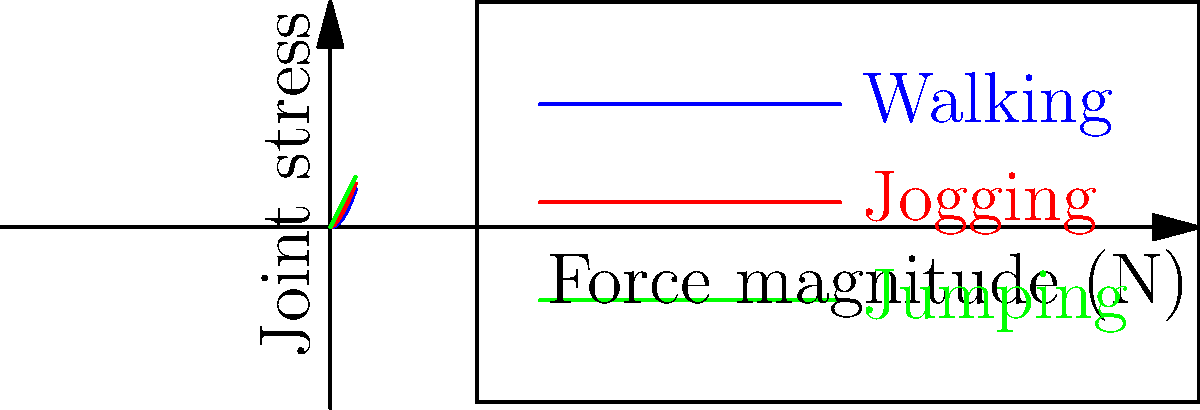In the context of teaching children about healthy exercise habits through virtual reality, consider the graph showing the relationship between force magnitude and joint stress for different activities. Which exercise type demonstrates the most rapid increase in joint stress as force magnitude increases, and how might this information be used to design safe VR experiences for children? To answer this question, let's analyze the graph step-by-step:

1. The graph shows three curves representing different exercise types: walking (blue), jogging (red), and jumping (green).

2. We need to compare the rate of increase in joint stress as force magnitude increases for each activity:
   - Walking (blue curve): Shows a gradual, curved increase
   - Jogging (red curve): Shows a steeper increase than walking
   - Jumping (green curve): Shows the steepest, linear increase

3. The steepness of the curve indicates how quickly joint stress increases with force magnitude. The steeper the curve, the more rapid the increase in joint stress.

4. Jumping (green line) has the steepest curve, indicating the most rapid increase in joint stress as force magnitude increases.

5. For designing safe VR experiences:
   a) Limit high-impact activities like jumping, especially for longer durations
   b) Encourage lower-impact activities like walking for extended periods
   c) Gradually introduce higher-impact activities as children build strength and proper form
   d) Use the VR environment to teach proper landing techniques for jumping to minimize joint stress
   e) Incorporate rest periods and cool-down activities in the VR experience

6. The VR system could use this information to:
   - Monitor and limit the frequency and duration of high-impact movements
   - Provide real-time feedback on form and technique to reduce joint stress
   - Gamify lower-impact exercises to make them more engaging for children

By understanding the relationship between force and joint stress in different activities, the VR experience can be designed to promote healthy exercise habits while minimizing the risk of joint injuries in children.
Answer: Jumping; use to limit high-impact activities, encourage proper form, and balance exercise types in VR experiences. 